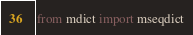<code> <loc_0><loc_0><loc_500><loc_500><_Python_>from mdict import mseqdict
</code> 